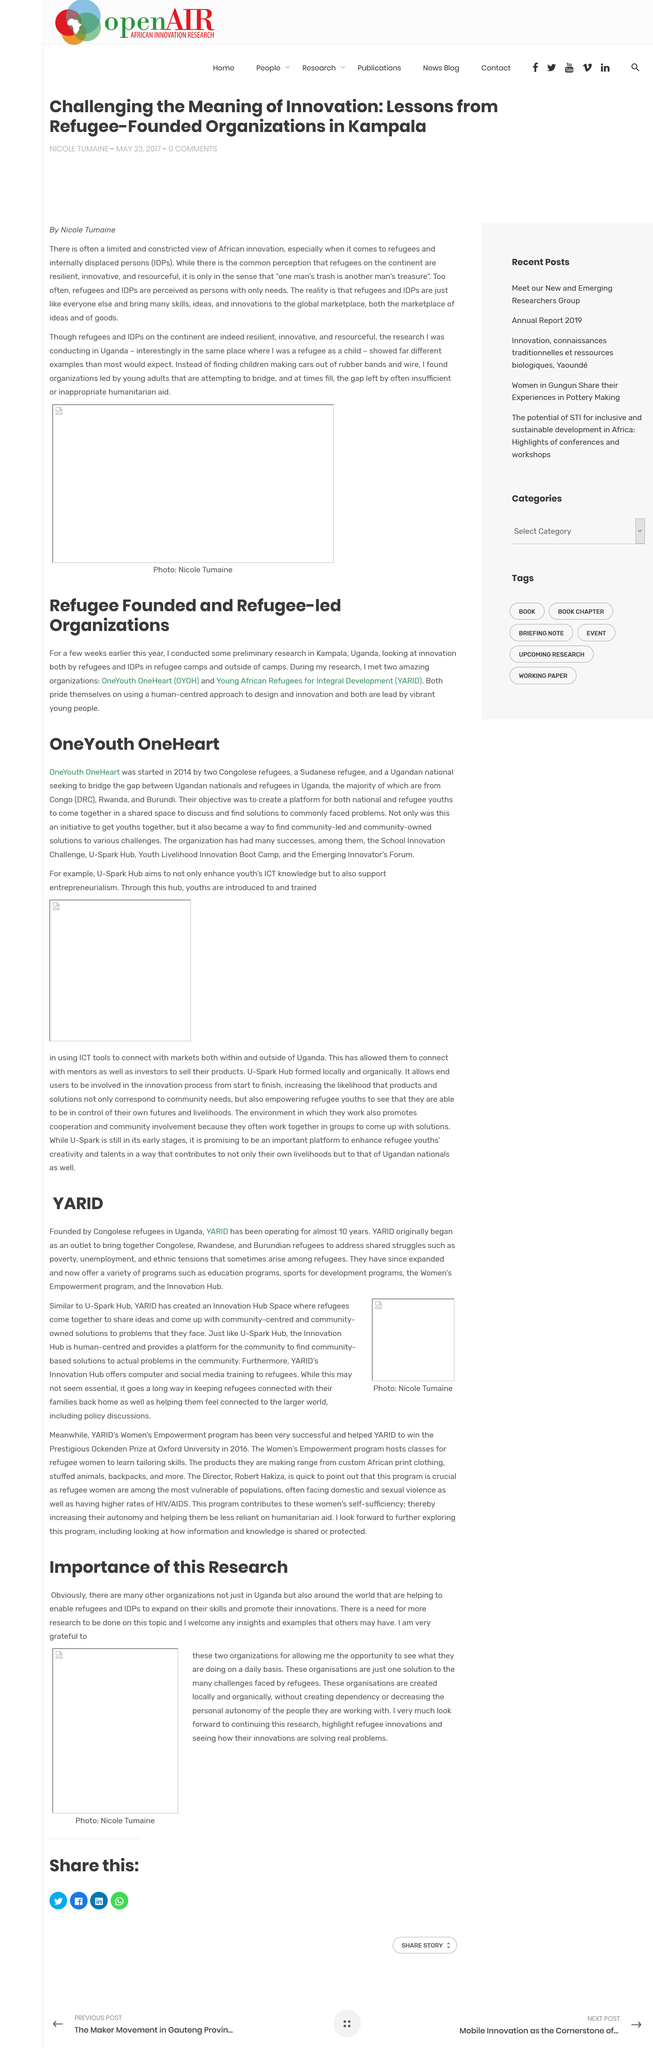Mention a couple of crucial points in this snapshot. OneYouth OneHeart was founded by three courageous individuals, two Congolese refugees, a Sudanese refugee, and a Ugandan national, who were determined to build bridges between Ugandan nationals and refugees in Uganda. OneYouth OneHeart was established in the year 2014. The author of the article titled "Challenging the Meaning of Innovation: Lessons from Refugee-Founded Organizations in Kampala" is Nicole Tumaine. The acronym IDPs stands for internally displaced persons, referring to individuals who have been forced to flee their homes and are currently residing within their own country's borders as a result of conflict, persecution, or natural disasters. OneYouth OneHeart was established with the objective of bringing together national and refugee youths in a shared space to discuss and find solutions to the common problems they face, thereby promoting understanding and cooperation between different communities. 